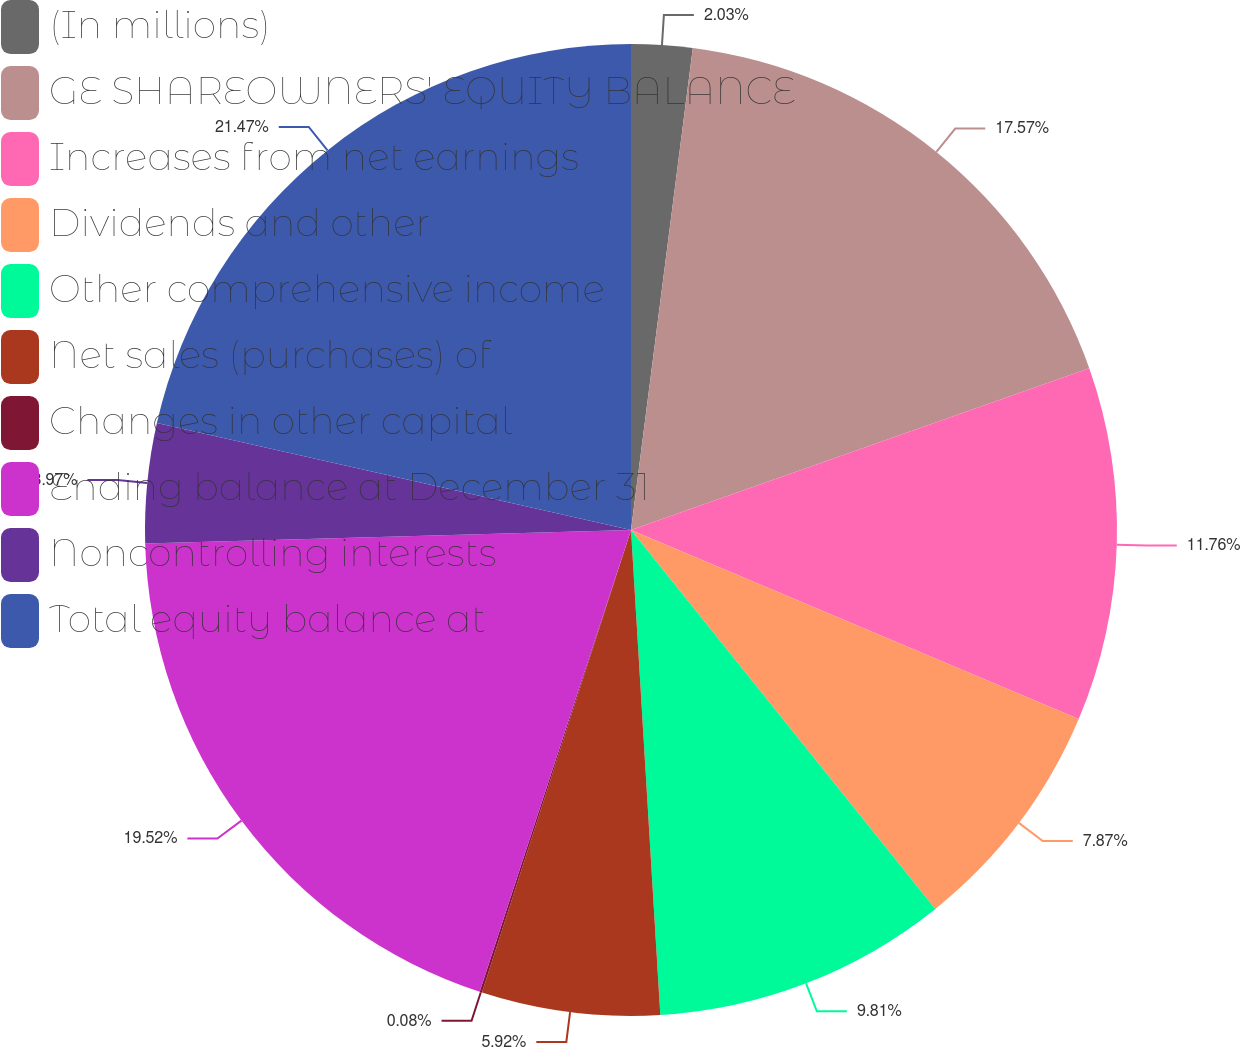Convert chart. <chart><loc_0><loc_0><loc_500><loc_500><pie_chart><fcel>(In millions)<fcel>GE SHAREOWNERS' EQUITY BALANCE<fcel>Increases from net earnings<fcel>Dividends and other<fcel>Other comprehensive income<fcel>Net sales (purchases) of<fcel>Changes in other capital<fcel>Ending balance at December 31<fcel>Noncontrolling interests<fcel>Total equity balance at<nl><fcel>2.03%<fcel>17.57%<fcel>11.76%<fcel>7.87%<fcel>9.81%<fcel>5.92%<fcel>0.08%<fcel>19.52%<fcel>3.97%<fcel>21.47%<nl></chart> 